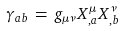Convert formula to latex. <formula><loc_0><loc_0><loc_500><loc_500>\gamma _ { a b } \, = \, g _ { \mu \nu } X ^ { \mu } _ { , a } X ^ { \nu } _ { , b }</formula> 